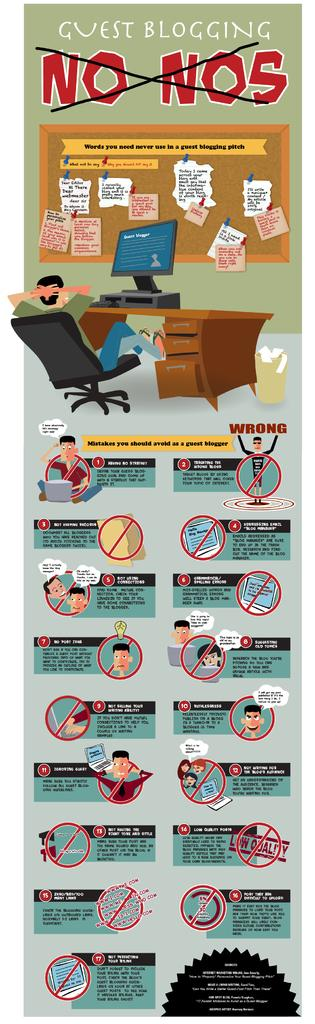What is featured on the poster in the image? The poster contains images of people. What can be seen on the table in the image? There is a monitor on a table in the image. Are there any symbols or signs in the image? Yes, caution symbols are present in the image. What type of information is displayed in the image? There is some information displayed in the image. What type of tail can be seen on the band in the image? There is no band or tail present in the image. How is the ice being used in the image? There is no ice present in the image. 